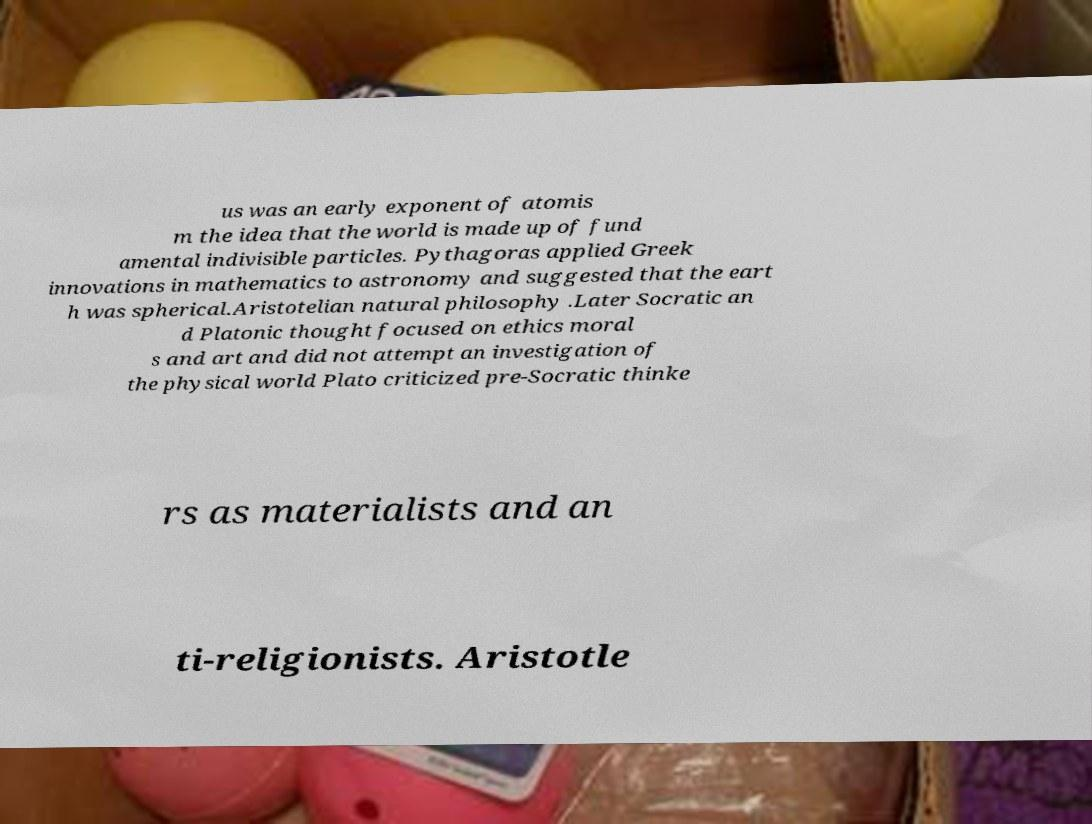Please identify and transcribe the text found in this image. us was an early exponent of atomis m the idea that the world is made up of fund amental indivisible particles. Pythagoras applied Greek innovations in mathematics to astronomy and suggested that the eart h was spherical.Aristotelian natural philosophy .Later Socratic an d Platonic thought focused on ethics moral s and art and did not attempt an investigation of the physical world Plato criticized pre-Socratic thinke rs as materialists and an ti-religionists. Aristotle 